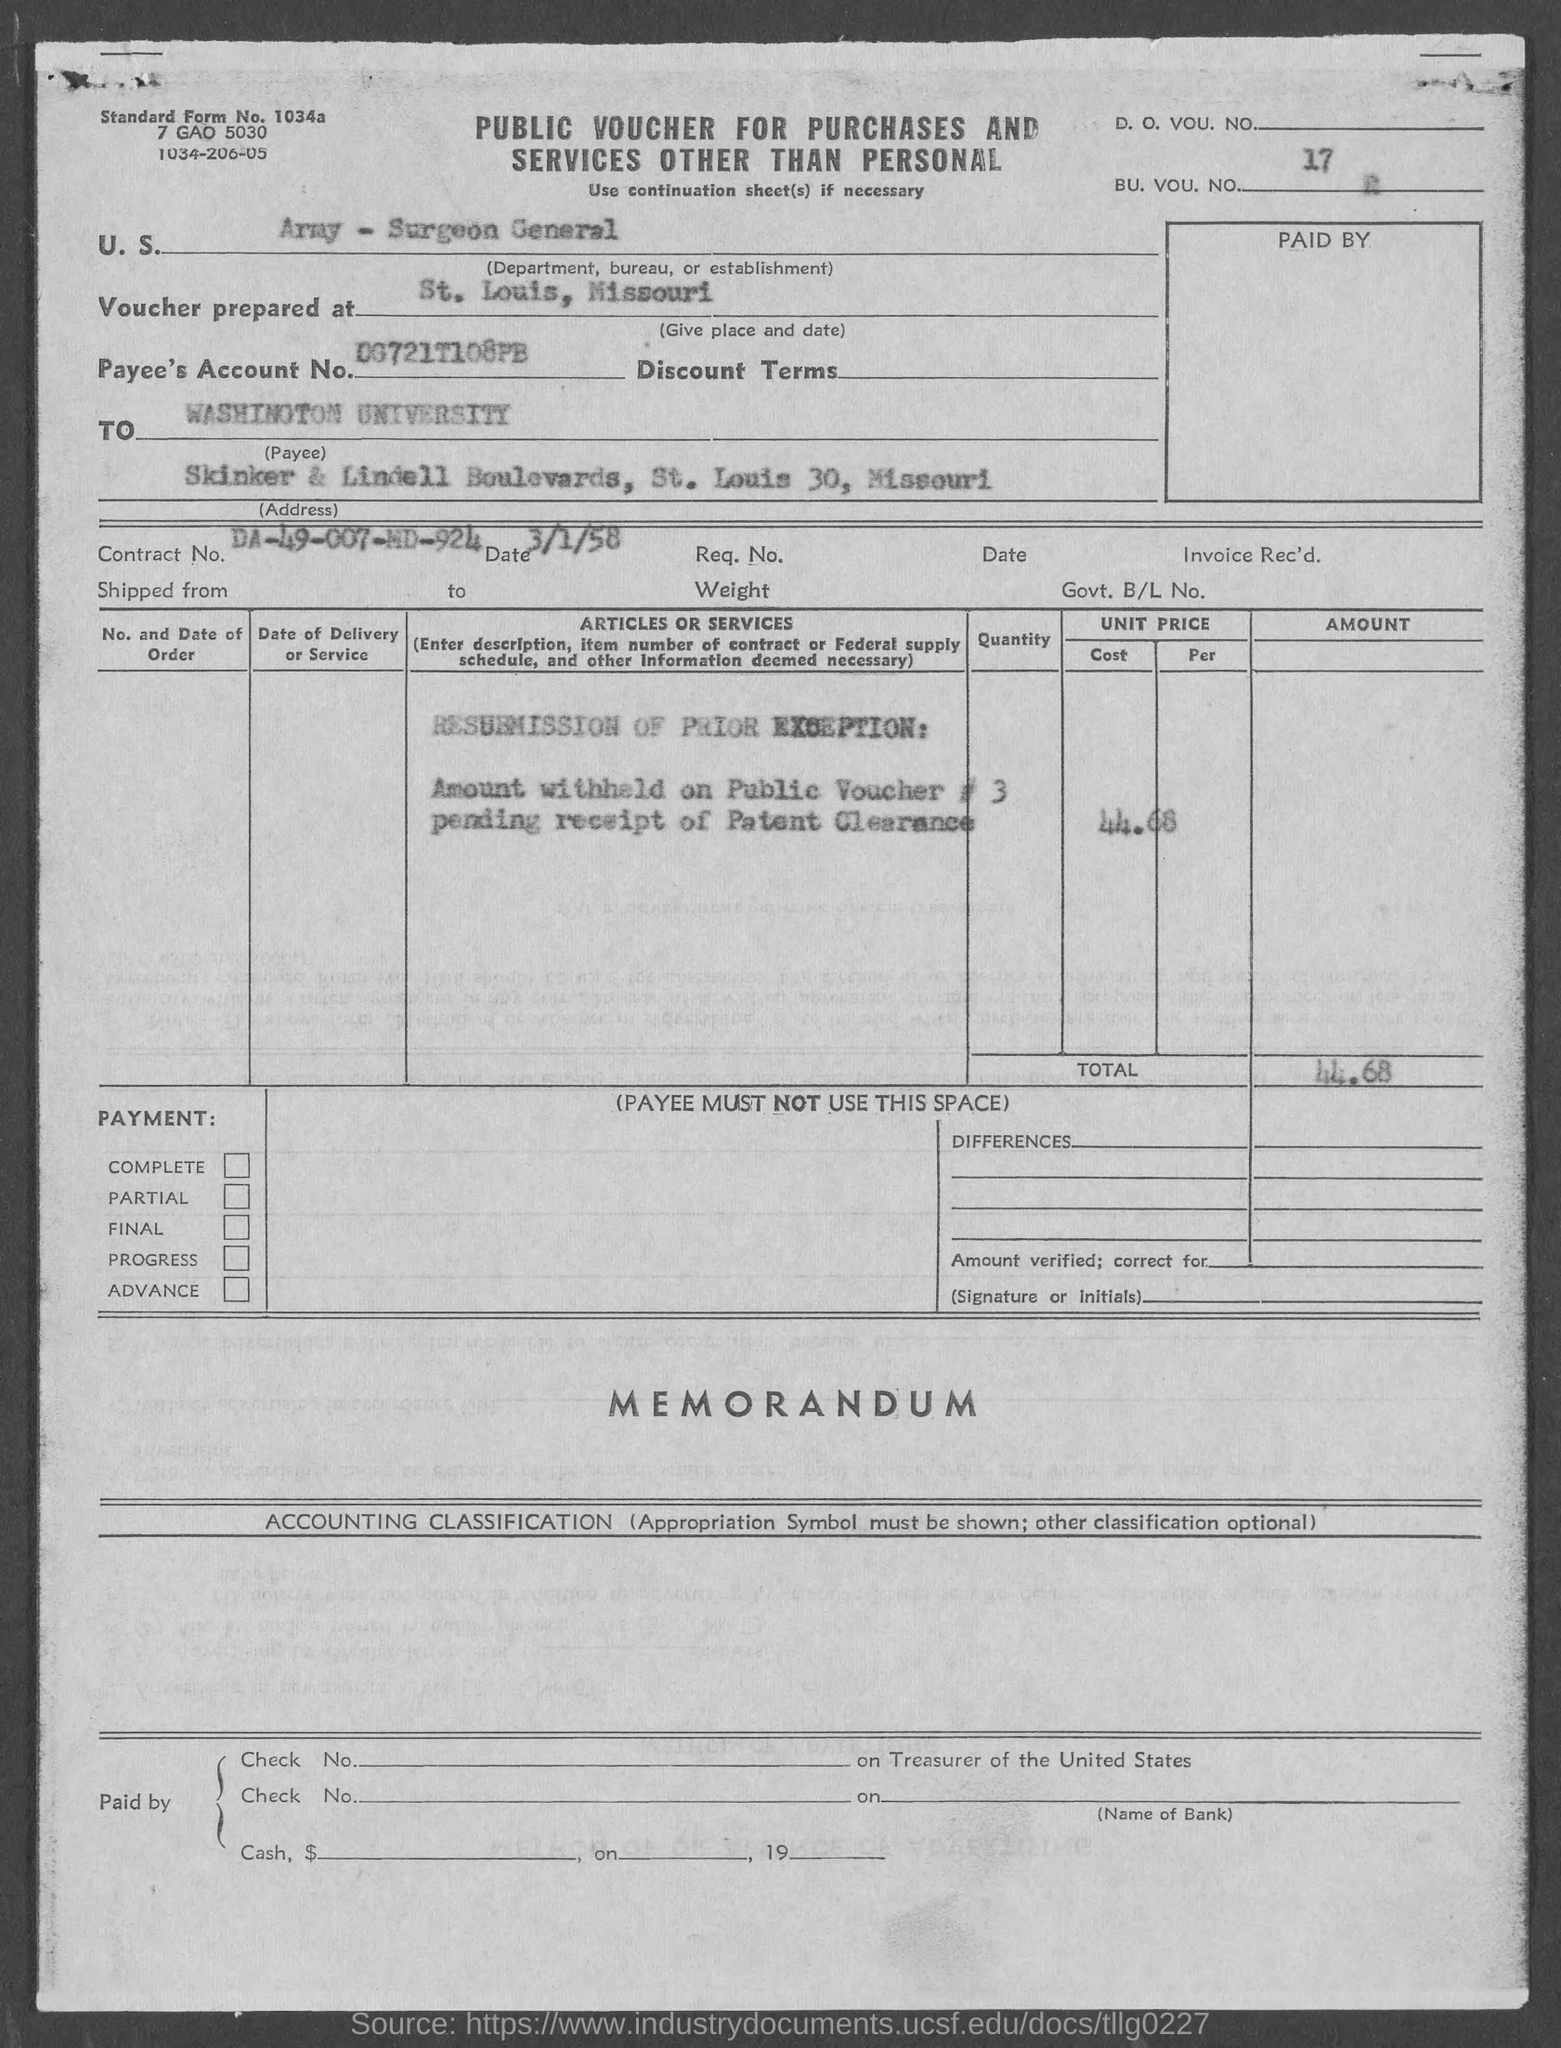What is the bu. vou. no.mentioned in the given form ?
Provide a succinct answer. 17. At which place the voucher was prepared as mentioned in the given form ?
Offer a very short reply. St. Louis, Missouri. What is the department , bureau or establishment mentioned in the given page ?
Keep it short and to the point. U.S. Army - Surgeon General. What is the payee's account no. mentioned in the given form ?
Ensure brevity in your answer.  DG721T108PB. What is the name of the university mentioned in the given form ?
Keep it short and to the point. Washington university. What is the total amount mentioned in the given form ?
Your answer should be compact. 44.68. What is the date mentioned in the given form ?
Provide a succinct answer. 3/1/58. What is the contract no. mentioned in the given form ?
Your answer should be very brief. DA-49-007-MD-924. What is the address given as mentioned in the given form ?
Ensure brevity in your answer.  Skinker & lindell boulevards, st. louis 30, missouri. 